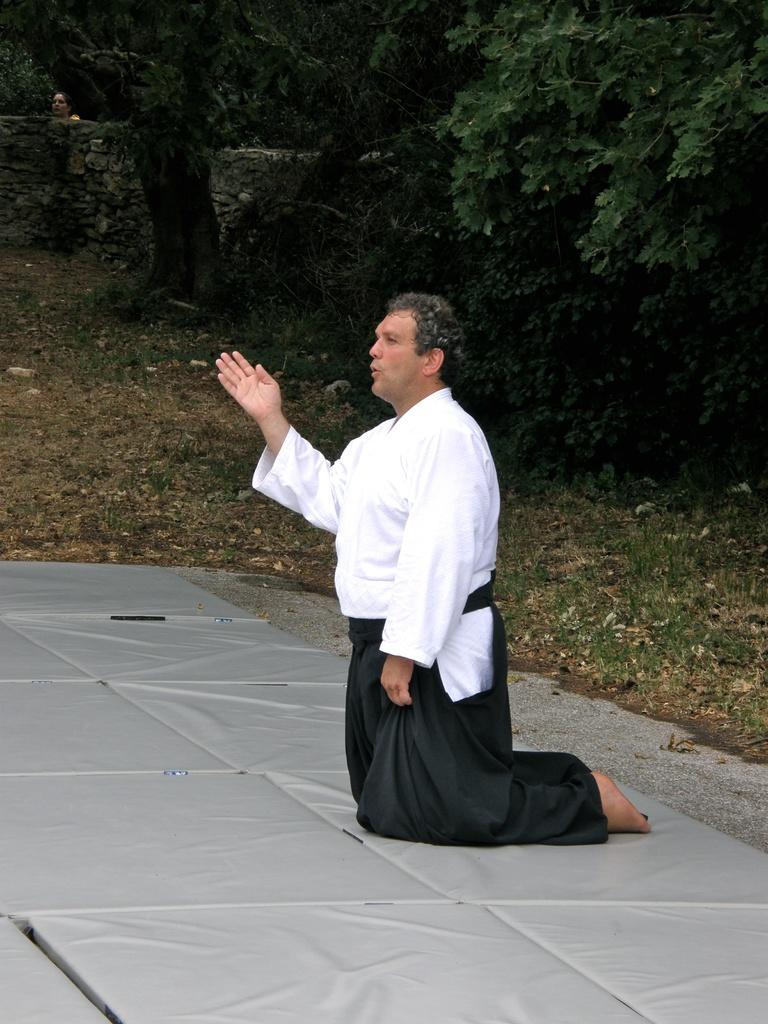How would you summarize this image in a sentence or two? In this picture there is a man in the center of the image and there is greenery in the background area of the image, there is another person behind the wall. 